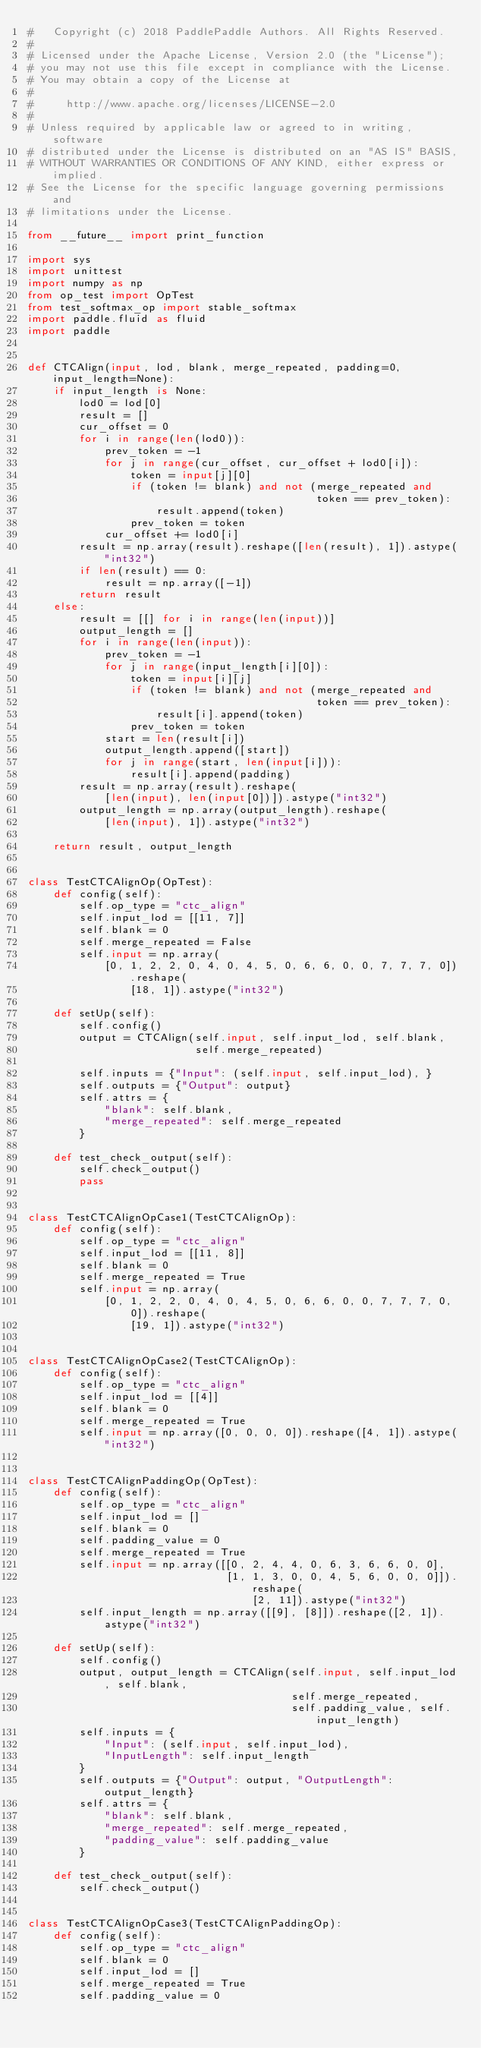Convert code to text. <code><loc_0><loc_0><loc_500><loc_500><_Python_>#   Copyright (c) 2018 PaddlePaddle Authors. All Rights Reserved.
#
# Licensed under the Apache License, Version 2.0 (the "License");
# you may not use this file except in compliance with the License.
# You may obtain a copy of the License at
#
#     http://www.apache.org/licenses/LICENSE-2.0
#
# Unless required by applicable law or agreed to in writing, software
# distributed under the License is distributed on an "AS IS" BASIS,
# WITHOUT WARRANTIES OR CONDITIONS OF ANY KIND, either express or implied.
# See the License for the specific language governing permissions and
# limitations under the License.

from __future__ import print_function

import sys
import unittest
import numpy as np
from op_test import OpTest
from test_softmax_op import stable_softmax
import paddle.fluid as fluid
import paddle


def CTCAlign(input, lod, blank, merge_repeated, padding=0, input_length=None):
    if input_length is None:
        lod0 = lod[0]
        result = []
        cur_offset = 0
        for i in range(len(lod0)):
            prev_token = -1
            for j in range(cur_offset, cur_offset + lod0[i]):
                token = input[j][0]
                if (token != blank) and not (merge_repeated and
                                             token == prev_token):
                    result.append(token)
                prev_token = token
            cur_offset += lod0[i]
        result = np.array(result).reshape([len(result), 1]).astype("int32")
        if len(result) == 0:
            result = np.array([-1])
        return result
    else:
        result = [[] for i in range(len(input))]
        output_length = []
        for i in range(len(input)):
            prev_token = -1
            for j in range(input_length[i][0]):
                token = input[i][j]
                if (token != blank) and not (merge_repeated and
                                             token == prev_token):
                    result[i].append(token)
                prev_token = token
            start = len(result[i])
            output_length.append([start])
            for j in range(start, len(input[i])):
                result[i].append(padding)
        result = np.array(result).reshape(
            [len(input), len(input[0])]).astype("int32")
        output_length = np.array(output_length).reshape(
            [len(input), 1]).astype("int32")

    return result, output_length


class TestCTCAlignOp(OpTest):
    def config(self):
        self.op_type = "ctc_align"
        self.input_lod = [[11, 7]]
        self.blank = 0
        self.merge_repeated = False
        self.input = np.array(
            [0, 1, 2, 2, 0, 4, 0, 4, 5, 0, 6, 6, 0, 0, 7, 7, 7, 0]).reshape(
                [18, 1]).astype("int32")

    def setUp(self):
        self.config()
        output = CTCAlign(self.input, self.input_lod, self.blank,
                          self.merge_repeated)

        self.inputs = {"Input": (self.input, self.input_lod), }
        self.outputs = {"Output": output}
        self.attrs = {
            "blank": self.blank,
            "merge_repeated": self.merge_repeated
        }

    def test_check_output(self):
        self.check_output()
        pass


class TestCTCAlignOpCase1(TestCTCAlignOp):
    def config(self):
        self.op_type = "ctc_align"
        self.input_lod = [[11, 8]]
        self.blank = 0
        self.merge_repeated = True
        self.input = np.array(
            [0, 1, 2, 2, 0, 4, 0, 4, 5, 0, 6, 6, 0, 0, 7, 7, 7, 0, 0]).reshape(
                [19, 1]).astype("int32")


class TestCTCAlignOpCase2(TestCTCAlignOp):
    def config(self):
        self.op_type = "ctc_align"
        self.input_lod = [[4]]
        self.blank = 0
        self.merge_repeated = True
        self.input = np.array([0, 0, 0, 0]).reshape([4, 1]).astype("int32")


class TestCTCAlignPaddingOp(OpTest):
    def config(self):
        self.op_type = "ctc_align"
        self.input_lod = []
        self.blank = 0
        self.padding_value = 0
        self.merge_repeated = True
        self.input = np.array([[0, 2, 4, 4, 0, 6, 3, 6, 6, 0, 0],
                               [1, 1, 3, 0, 0, 4, 5, 6, 0, 0, 0]]).reshape(
                                   [2, 11]).astype("int32")
        self.input_length = np.array([[9], [8]]).reshape([2, 1]).astype("int32")

    def setUp(self):
        self.config()
        output, output_length = CTCAlign(self.input, self.input_lod, self.blank,
                                         self.merge_repeated,
                                         self.padding_value, self.input_length)
        self.inputs = {
            "Input": (self.input, self.input_lod),
            "InputLength": self.input_length
        }
        self.outputs = {"Output": output, "OutputLength": output_length}
        self.attrs = {
            "blank": self.blank,
            "merge_repeated": self.merge_repeated,
            "padding_value": self.padding_value
        }

    def test_check_output(self):
        self.check_output()


class TestCTCAlignOpCase3(TestCTCAlignPaddingOp):
    def config(self):
        self.op_type = "ctc_align"
        self.blank = 0
        self.input_lod = []
        self.merge_repeated = True
        self.padding_value = 0</code> 